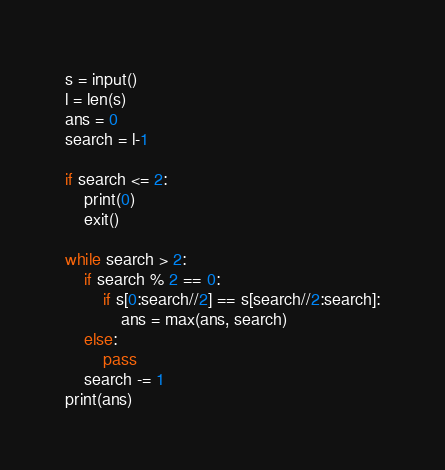<code> <loc_0><loc_0><loc_500><loc_500><_Python_>s = input()
l = len(s)
ans = 0
search = l-1

if search <= 2:
    print(0)
    exit()

while search > 2:
    if search % 2 == 0:
        if s[0:search//2] == s[search//2:search]:
            ans = max(ans, search)
    else:
        pass
    search -= 1
print(ans)</code> 